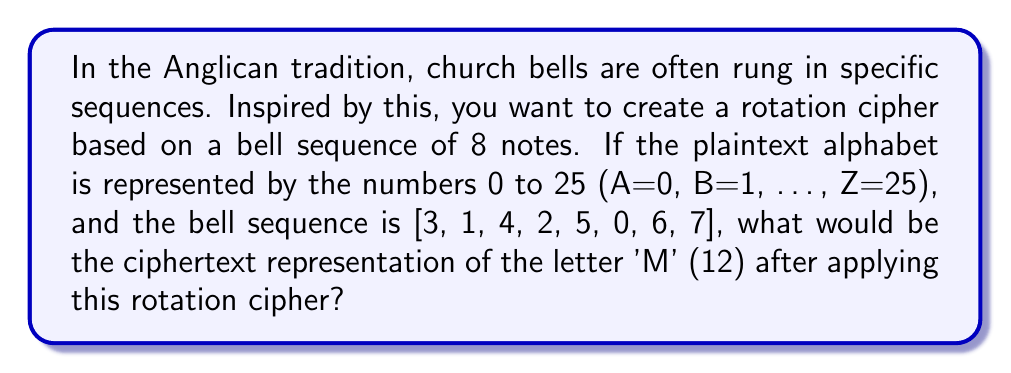Teach me how to tackle this problem. Let's approach this step-by-step:

1) First, we need to understand how the rotation cipher works. Each position in the plaintext is shifted by the corresponding value in the bell sequence.

2) The letter 'M' is represented by 12 in our numeric alphabet (A=0, B=1, ..., M=12, ..., Z=25).

3) The bell sequence is [3, 1, 4, 2, 5, 0, 6, 7]. Since 'M' is the 13th letter of the alphabet (index 12), we use the 5th element of the bell sequence (because 12 ≡ 4 (mod 8), and we start counting from 0). The 5th element is 5.

4) We need to shift 12 by 5 positions. This is done using modular arithmetic:

   $$(12 + 5) \mod 26 = 17 \mod 26 = 17$$

5) In our alphabet, 17 corresponds to the letter 'R'.

Therefore, the letter 'M' would be encrypted as 'R' using this rotation cipher inspired by the church bell sequence.
Answer: 17 (or 'R') 